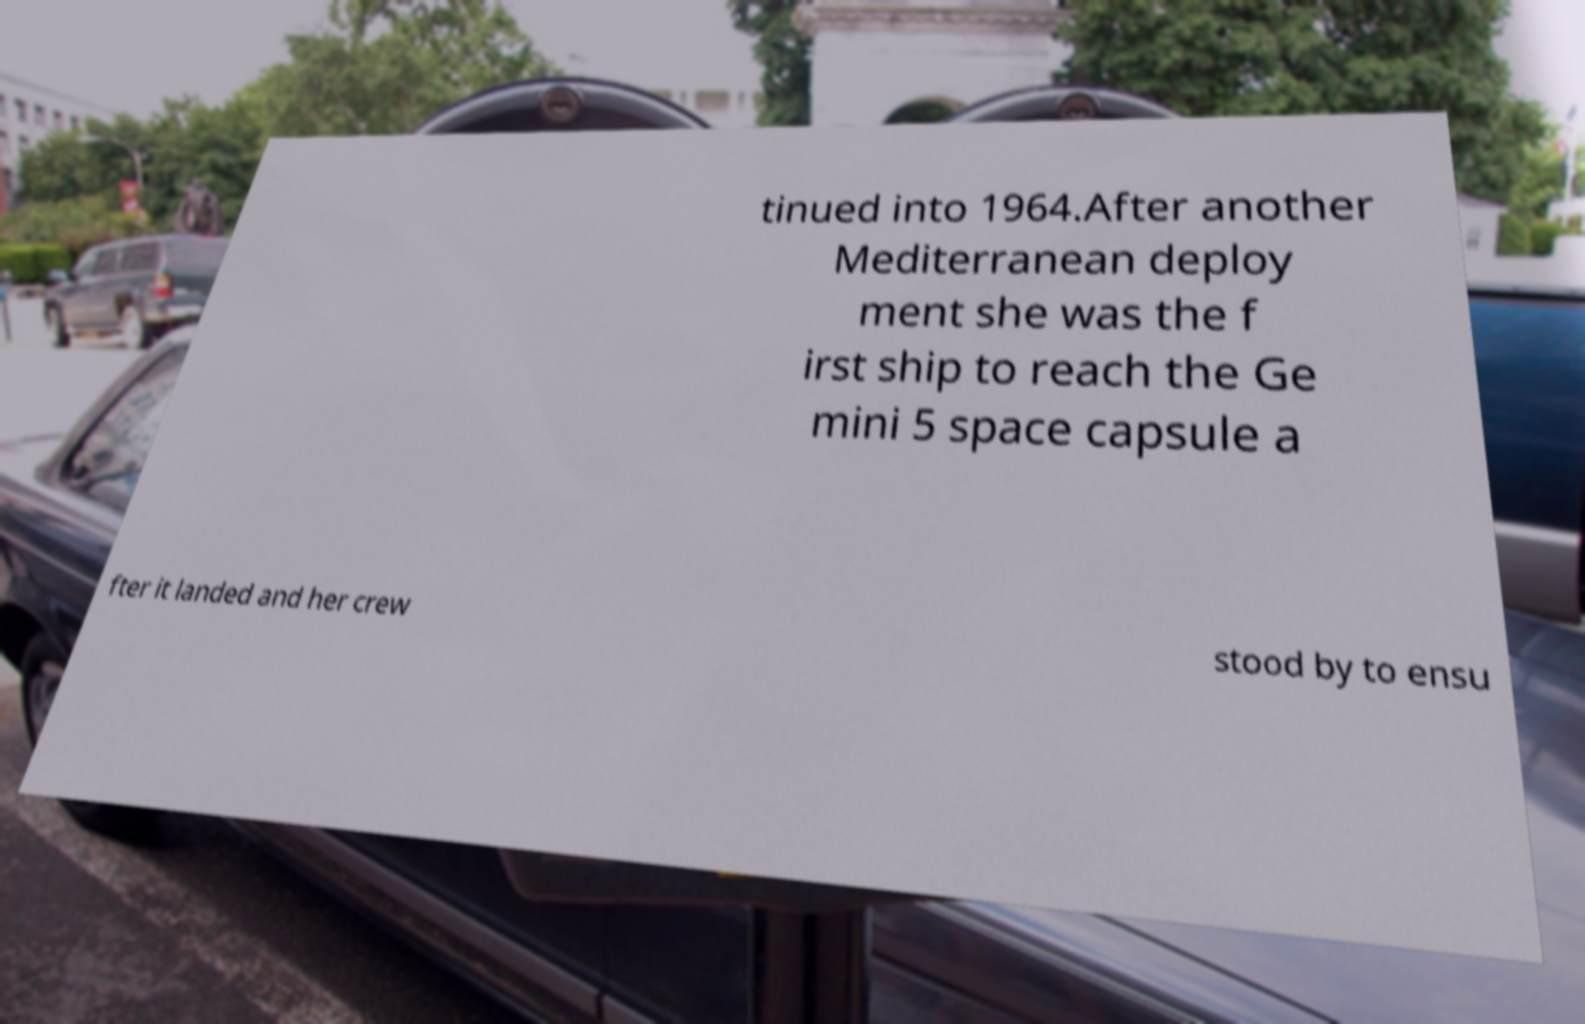Could you extract and type out the text from this image? tinued into 1964.After another Mediterranean deploy ment she was the f irst ship to reach the Ge mini 5 space capsule a fter it landed and her crew stood by to ensu 